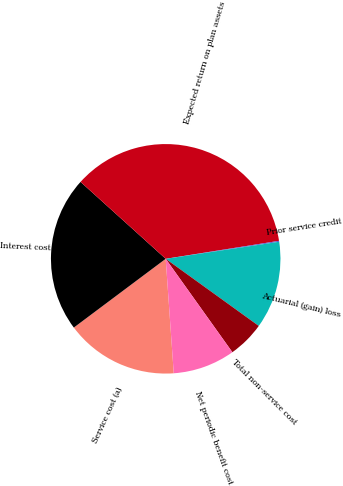Convert chart. <chart><loc_0><loc_0><loc_500><loc_500><pie_chart><fcel>Service cost (a)<fcel>Interest cost<fcel>Expected return on plan assets<fcel>Prior service credit<fcel>Actuarial (gain) loss<fcel>Total non-service cost<fcel>Net periodic benefit cost<nl><fcel>15.89%<fcel>21.92%<fcel>35.8%<fcel>0.13%<fcel>12.32%<fcel>5.19%<fcel>8.75%<nl></chart> 